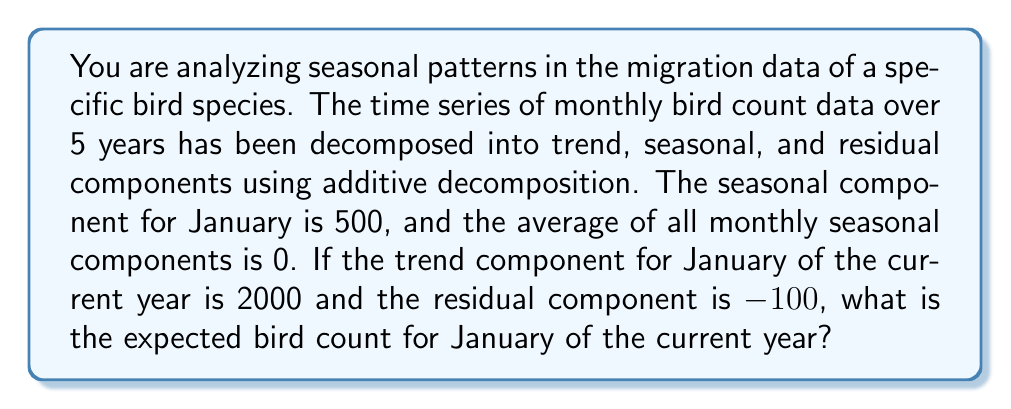Can you solve this math problem? To solve this problem, we need to understand the components of time series decomposition and how they relate to the original data. In additive decomposition, we have:

$$ Y_t = T_t + S_t + R_t $$

Where:
$Y_t$ is the original time series
$T_t$ is the trend component
$S_t$ is the seasonal component
$R_t$ is the residual component

Given information:
1. Seasonal component for January: $S_{Jan} = 500$
2. Average of all monthly seasonal components: $\bar{S} = 0$
3. Trend component for January of the current year: $T_{Jan} = 2000$
4. Residual component: $R_{Jan} = -100$

To find the expected bird count for January, we need to sum these components:

$$ Y_{Jan} = T_{Jan} + S_{Jan} + R_{Jan} $$

Substituting the given values:

$$ Y_{Jan} = 2000 + 500 + (-100) $$

Calculating:

$$ Y_{Jan} = 2400 $$

This result represents the expected bird count for January of the current year, taking into account the trend, seasonal pattern, and random variation.
Answer: 2400 birds 